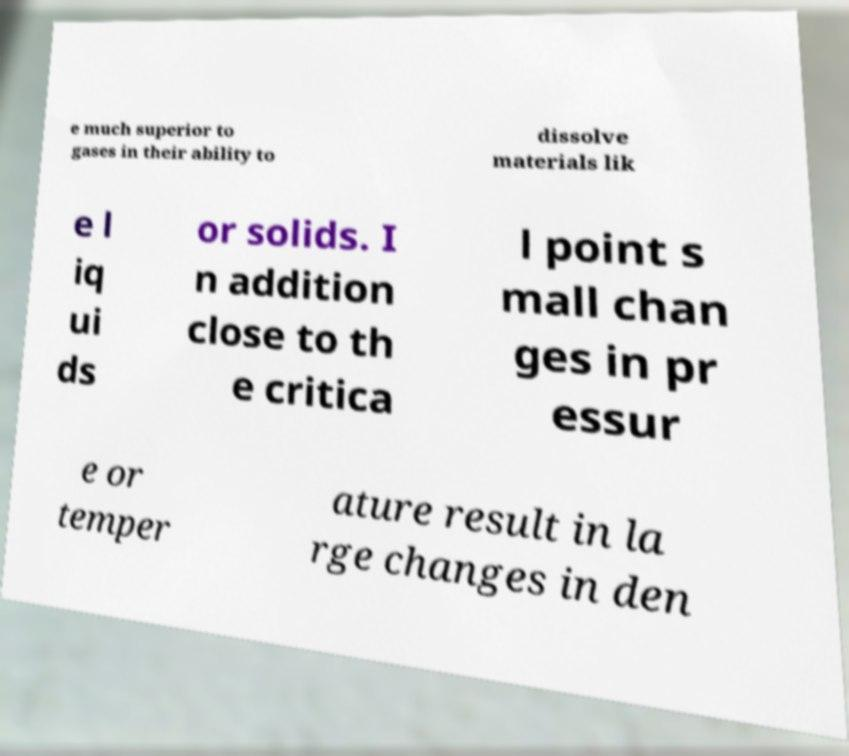For documentation purposes, I need the text within this image transcribed. Could you provide that? e much superior to gases in their ability to dissolve materials lik e l iq ui ds or solids. I n addition close to th e critica l point s mall chan ges in pr essur e or temper ature result in la rge changes in den 